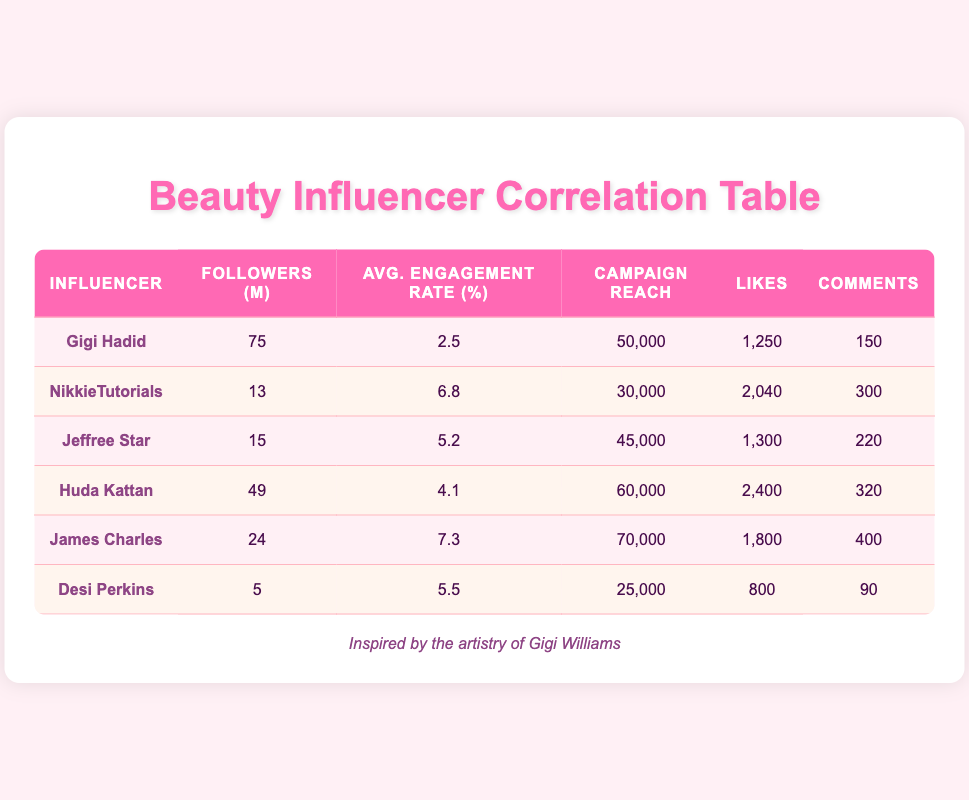What is the average engagement rate among the influencers listed? To find the average engagement rate, first, we sum the engagement rates: 2.5 + 6.8 + 5.2 + 4.1 + 7.3 + 5.5 = 31.4. Then, we divide by the number of influencers: 31.4 / 6 = 5.23.
Answer: 5.23 Which influencer has the highest campaign reach? The influencer with the highest campaign reach is James Charles with a reach of 70,000.
Answer: James Charles How many total likes did the influencers receive? We calculate the total likes by summing each influencer's likes: 1250 + 2040 + 1300 + 2400 + 1800 + 800 = 10090.
Answer: 10090 Is NikkieTutorials' average engagement rate higher than Gigi Hadid's? NikkieTutorials has an engagement rate of 6.8, which is higher than Gigi Hadid's engagement rate of 2.5.
Answer: Yes What percentage of total comments did Huda Kattan receive compared to the total comments of all influencers? First, we sum the total comments: 150 + 300 + 220 + 320 + 400 + 90 = 1480. Huda Kattan received 320 comments, so her percentage is (320 / 1480) * 100 = 21.62%.
Answer: 21.62% Which influencer has the lowest follower count? Desi Perkins has the lowest follower count with 5 million followers.
Answer: Desi Perkins If we were to rank the influencers by their average engagement rate, which position would Gigi Hadid be in? The engagement rates in descending order are: James Charles (7.3), NikkieTutorials (6.8), Jeffree Star (5.2), Huda Kattan (4.1), Desi Perkins (5.5), Gigi Hadid (2.5). Gigi Hadid ranks 6th.
Answer: 6th What is the difference in campaign reach between the influencer with the most followers and the one with the least followers? Gigi Hadid has 75 million followers and a campaign reach of 50,000, while Desi Perkins has 5 million followers and a campaign reach of 25,000. The difference in reach is 50,000 - 25,000 = 25,000.
Answer: 25,000 